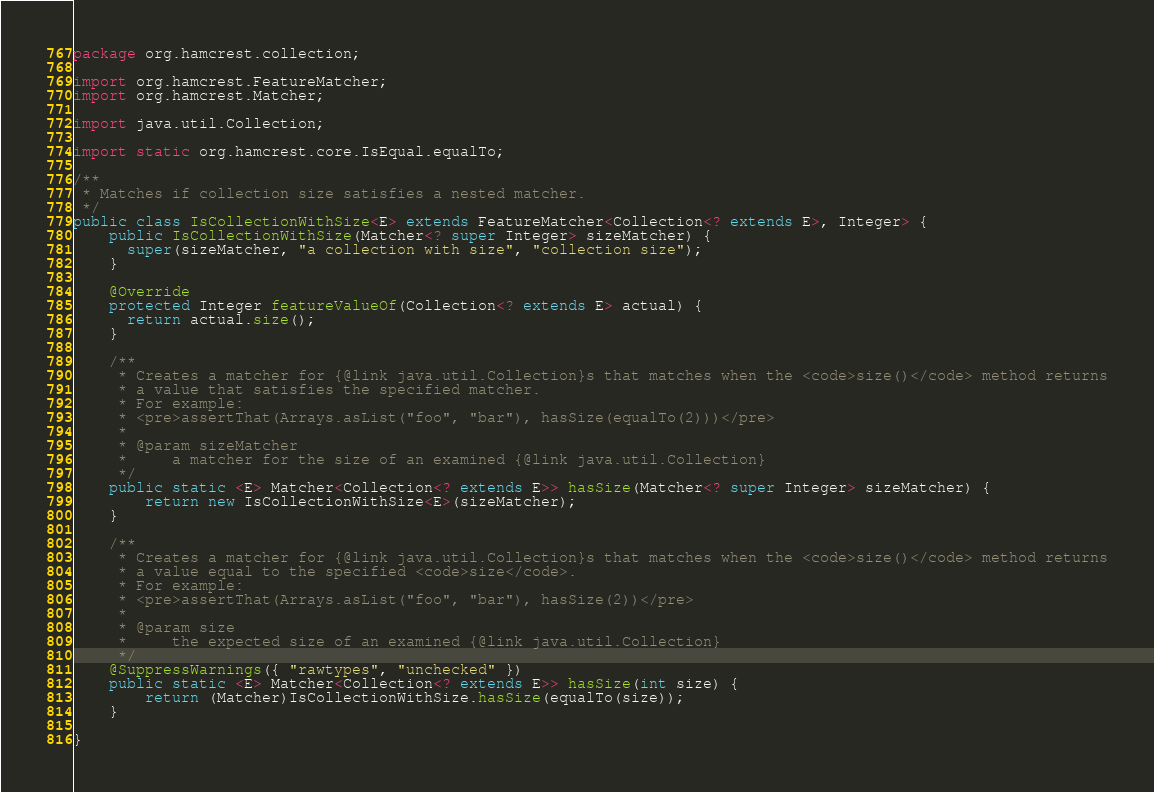Convert code to text. <code><loc_0><loc_0><loc_500><loc_500><_Java_>package org.hamcrest.collection;

import org.hamcrest.FeatureMatcher;
import org.hamcrest.Matcher;

import java.util.Collection;

import static org.hamcrest.core.IsEqual.equalTo;

/**
 * Matches if collection size satisfies a nested matcher.
 */
public class IsCollectionWithSize<E> extends FeatureMatcher<Collection<? extends E>, Integer> {
    public IsCollectionWithSize(Matcher<? super Integer> sizeMatcher) {
      super(sizeMatcher, "a collection with size", "collection size");
    }

    @Override
    protected Integer featureValueOf(Collection<? extends E> actual) {
      return actual.size();
    }

    /**
     * Creates a matcher for {@link java.util.Collection}s that matches when the <code>size()</code> method returns
     * a value that satisfies the specified matcher.
     * For example:
     * <pre>assertThat(Arrays.asList("foo", "bar"), hasSize(equalTo(2)))</pre>
     * 
     * @param sizeMatcher
     *     a matcher for the size of an examined {@link java.util.Collection}
     */
    public static <E> Matcher<Collection<? extends E>> hasSize(Matcher<? super Integer> sizeMatcher) {
        return new IsCollectionWithSize<E>(sizeMatcher);
    }

    /**
     * Creates a matcher for {@link java.util.Collection}s that matches when the <code>size()</code> method returns
     * a value equal to the specified <code>size</code>.
     * For example:
     * <pre>assertThat(Arrays.asList("foo", "bar"), hasSize(2))</pre>
     * 
     * @param size
     *     the expected size of an examined {@link java.util.Collection}
     */
    @SuppressWarnings({ "rawtypes", "unchecked" })
    public static <E> Matcher<Collection<? extends E>> hasSize(int size) {
        return (Matcher)IsCollectionWithSize.hasSize(equalTo(size));
    }

}
</code> 